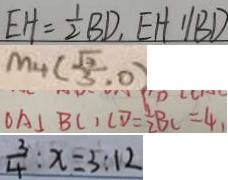Convert formula to latex. <formula><loc_0><loc_0><loc_500><loc_500>E H = \frac { 1 } { 2 } B D , E H / / B D 
 M _ { 4 } ( \frac { \sqrt { 3 } } { 3 } , 0 ) 
 O A \bot B C , C D = \frac { 1 } { 2 } B C = 4 
 \frac { 3 } { 4 } : x = 3 : 1 2</formula> 